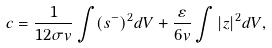Convert formula to latex. <formula><loc_0><loc_0><loc_500><loc_500>c = \frac { 1 } { 1 2 \sigma v } \int ( s ^ { - } ) ^ { 2 } d V + \frac { \varepsilon } { 6 v } \int | z | ^ { 2 } d V ,</formula> 